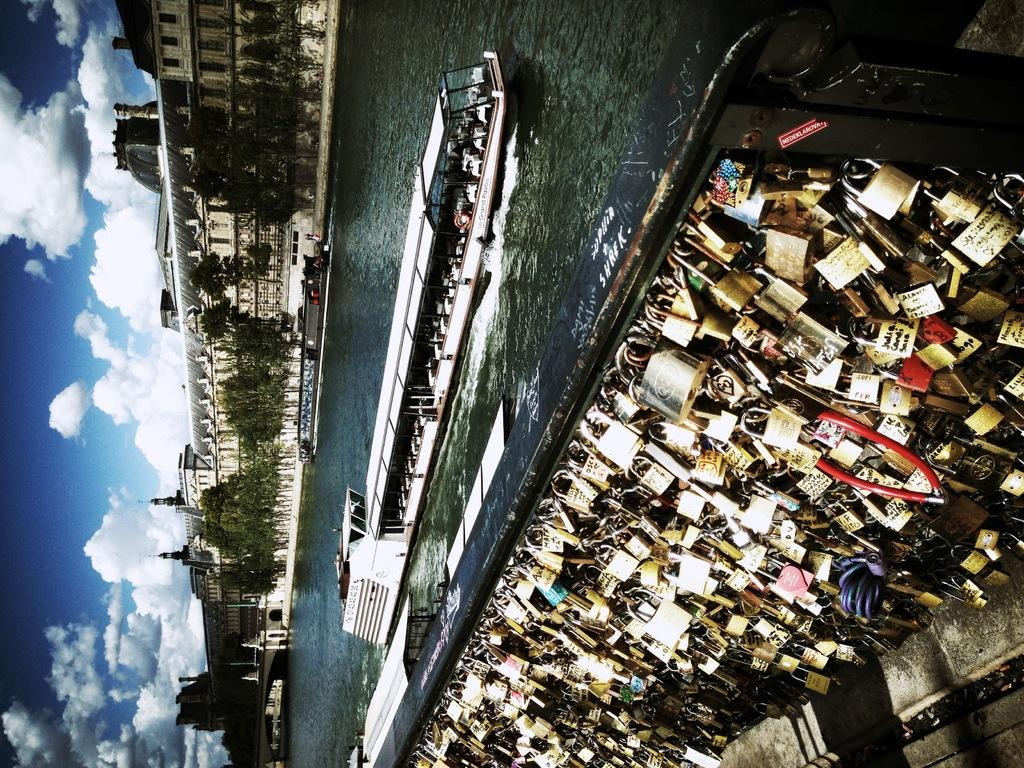What is the main subject of the image? The main subject of the image is a group of locks. What else can be seen in the image besides the locks? There is a ship on the water and buildings, trees, and the sky are visible in the background of the image. What is the condition of the sky in the image? The sky is visible in the background of the image, and clouds are present. What type of bird can be seen flying over the ocean in the image? There is no ocean present in the image, and no bird is visible. 